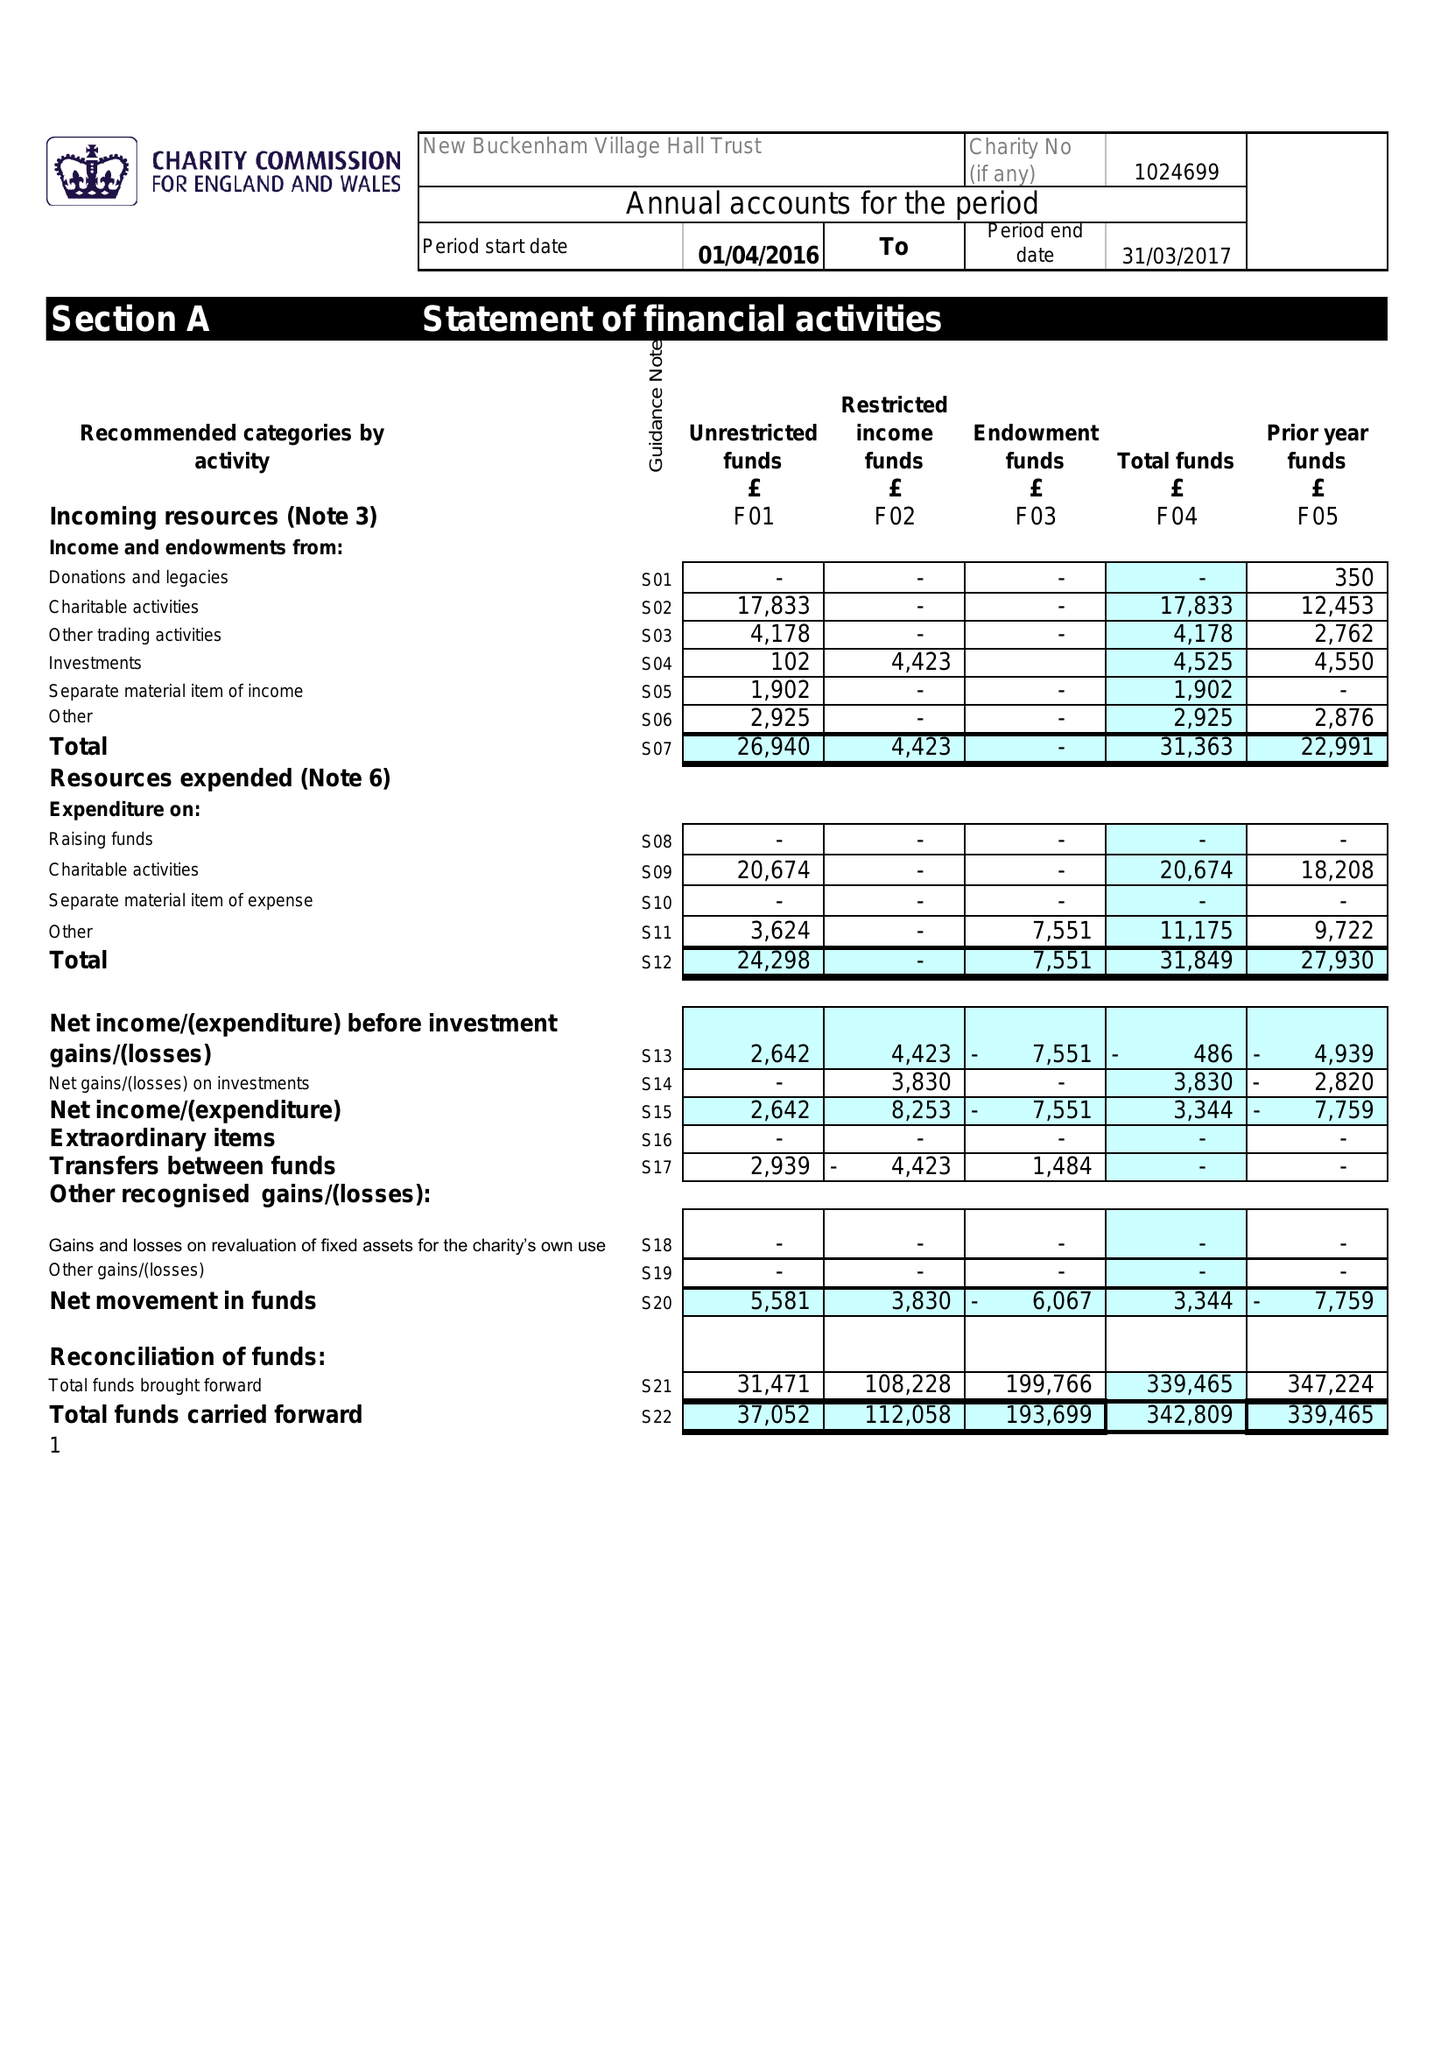What is the value for the charity_name?
Answer the question using a single word or phrase. New Buckenham New Village Hall 